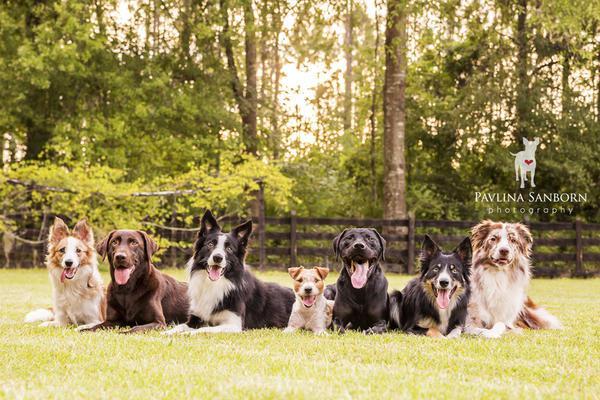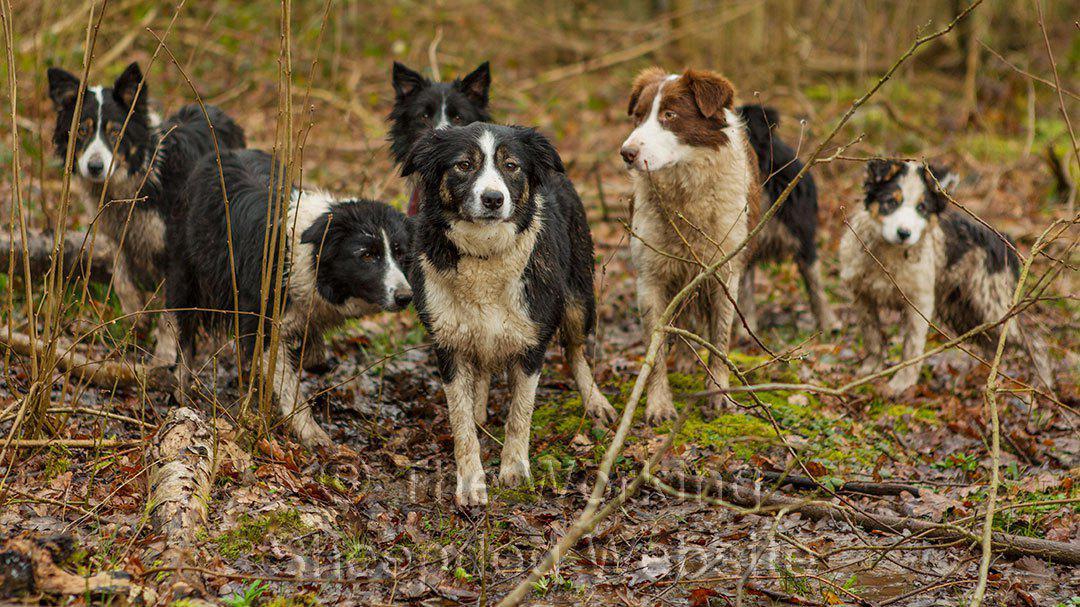The first image is the image on the left, the second image is the image on the right. Evaluate the accuracy of this statement regarding the images: "An image shows a nozzle spraying water at a group of black-and-white dogs.". Is it true? Answer yes or no. No. The first image is the image on the left, the second image is the image on the right. Assess this claim about the two images: "There are at least half a dozen dogs lying in a line on the grass in one of the images.". Correct or not? Answer yes or no. Yes. 